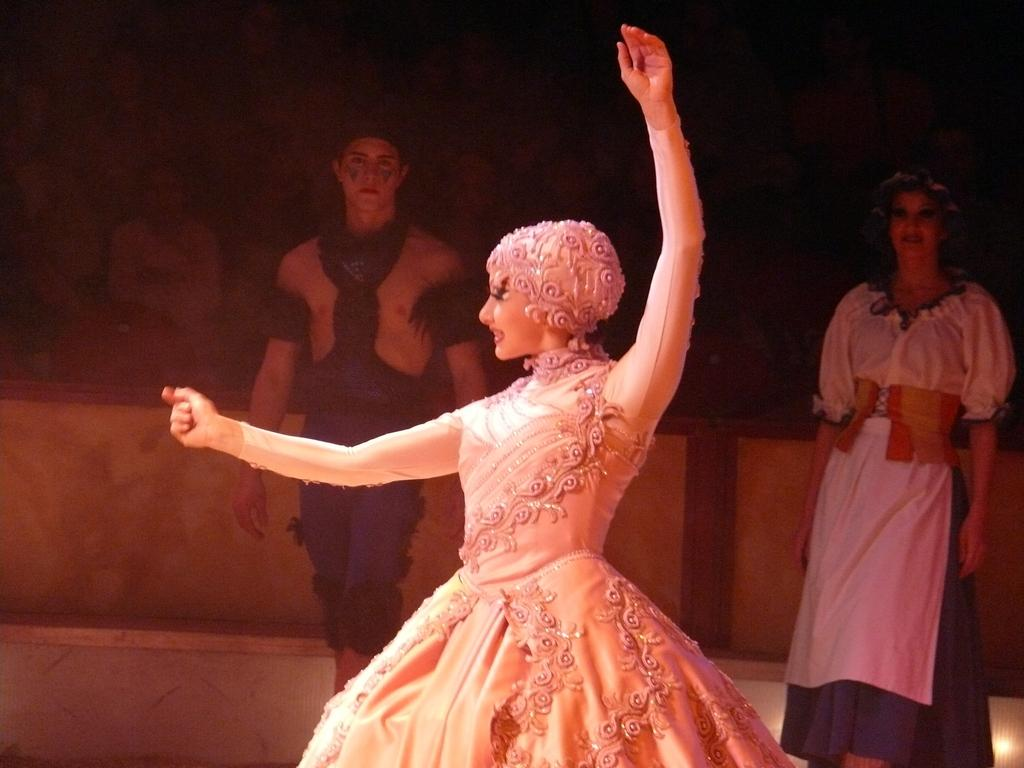What is the main subject in the middle of the image? There is a girl doll in the middle of the image. Are there any other dolls visible in the image? Yes, there are two other dolls in the background of the image. How are the other dolls positioned in relation to the girl doll? The other dolls are on either side of the girl doll. What activity does the girl doll appear to be engaged in? The girl doll appears to be a dancing doll. Can you tell me how many firemen are present in the image? There are no firemen present in the image; it features dolls. What type of bushes can be seen in the image? There are no bushes present in the image; it features dolls. 